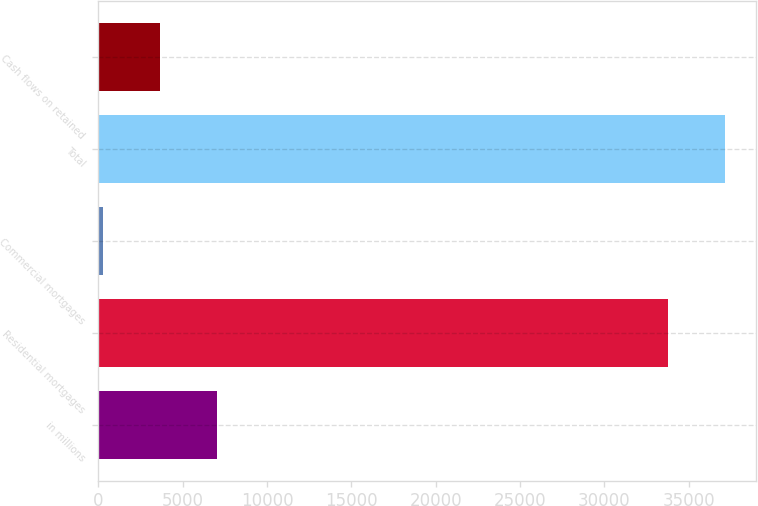Convert chart. <chart><loc_0><loc_0><loc_500><loc_500><bar_chart><fcel>in millions<fcel>Residential mortgages<fcel>Commercial mortgages<fcel>Total<fcel>Cash flows on retained<nl><fcel>7051<fcel>33755<fcel>300<fcel>37130.5<fcel>3675.5<nl></chart> 